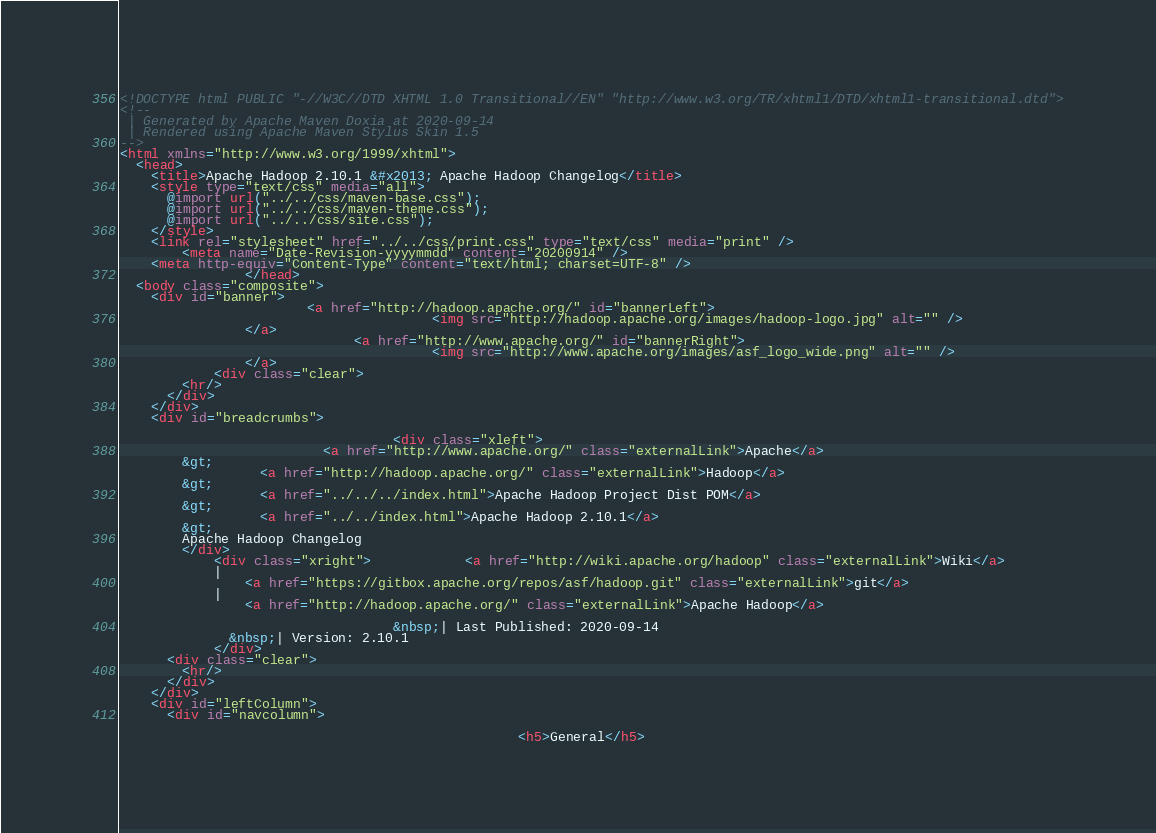<code> <loc_0><loc_0><loc_500><loc_500><_HTML_><!DOCTYPE html PUBLIC "-//W3C//DTD XHTML 1.0 Transitional//EN" "http://www.w3.org/TR/xhtml1/DTD/xhtml1-transitional.dtd">
<!--
 | Generated by Apache Maven Doxia at 2020-09-14
 | Rendered using Apache Maven Stylus Skin 1.5
-->
<html xmlns="http://www.w3.org/1999/xhtml">
  <head>
    <title>Apache Hadoop 2.10.1 &#x2013; Apache Hadoop Changelog</title>
    <style type="text/css" media="all">
      @import url("../../css/maven-base.css");
      @import url("../../css/maven-theme.css");
      @import url("../../css/site.css");
    </style>
    <link rel="stylesheet" href="../../css/print.css" type="text/css" media="print" />
        <meta name="Date-Revision-yyyymmdd" content="20200914" />
    <meta http-equiv="Content-Type" content="text/html; charset=UTF-8" />
                </head>
  <body class="composite">
    <div id="banner">
                        <a href="http://hadoop.apache.org/" id="bannerLeft">
                                        <img src="http://hadoop.apache.org/images/hadoop-logo.jpg" alt="" />
                </a>
                              <a href="http://www.apache.org/" id="bannerRight">
                                        <img src="http://www.apache.org/images/asf_logo_wide.png" alt="" />
                </a>
            <div class="clear">
        <hr/>
      </div>
    </div>
    <div id="breadcrumbs">
            
                                   <div class="xleft">
                          <a href="http://www.apache.org/" class="externalLink">Apache</a>
        &gt;
                  <a href="http://hadoop.apache.org/" class="externalLink">Hadoop</a>
        &gt;
                  <a href="../../../index.html">Apache Hadoop Project Dist POM</a>
        &gt;
                  <a href="../../index.html">Apache Hadoop 2.10.1</a>
        &gt;
        Apache Hadoop Changelog
        </div>
            <div class="xright">            <a href="http://wiki.apache.org/hadoop" class="externalLink">Wiki</a>
            |
                <a href="https://gitbox.apache.org/repos/asf/hadoop.git" class="externalLink">git</a>
            |
                <a href="http://hadoop.apache.org/" class="externalLink">Apache Hadoop</a>
              
                                   &nbsp;| Last Published: 2020-09-14
              &nbsp;| Version: 2.10.1
            </div>
      <div class="clear">
        <hr/>
      </div>
    </div>
    <div id="leftColumn">
      <div id="navcolumn">
             
                                                   <h5>General</h5></code> 